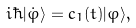<formula> <loc_0><loc_0><loc_500><loc_500>i \hbar { | } \dot { \varphi } \rangle = c _ { 1 } ( t ) | \varphi \rangle ,</formula> 